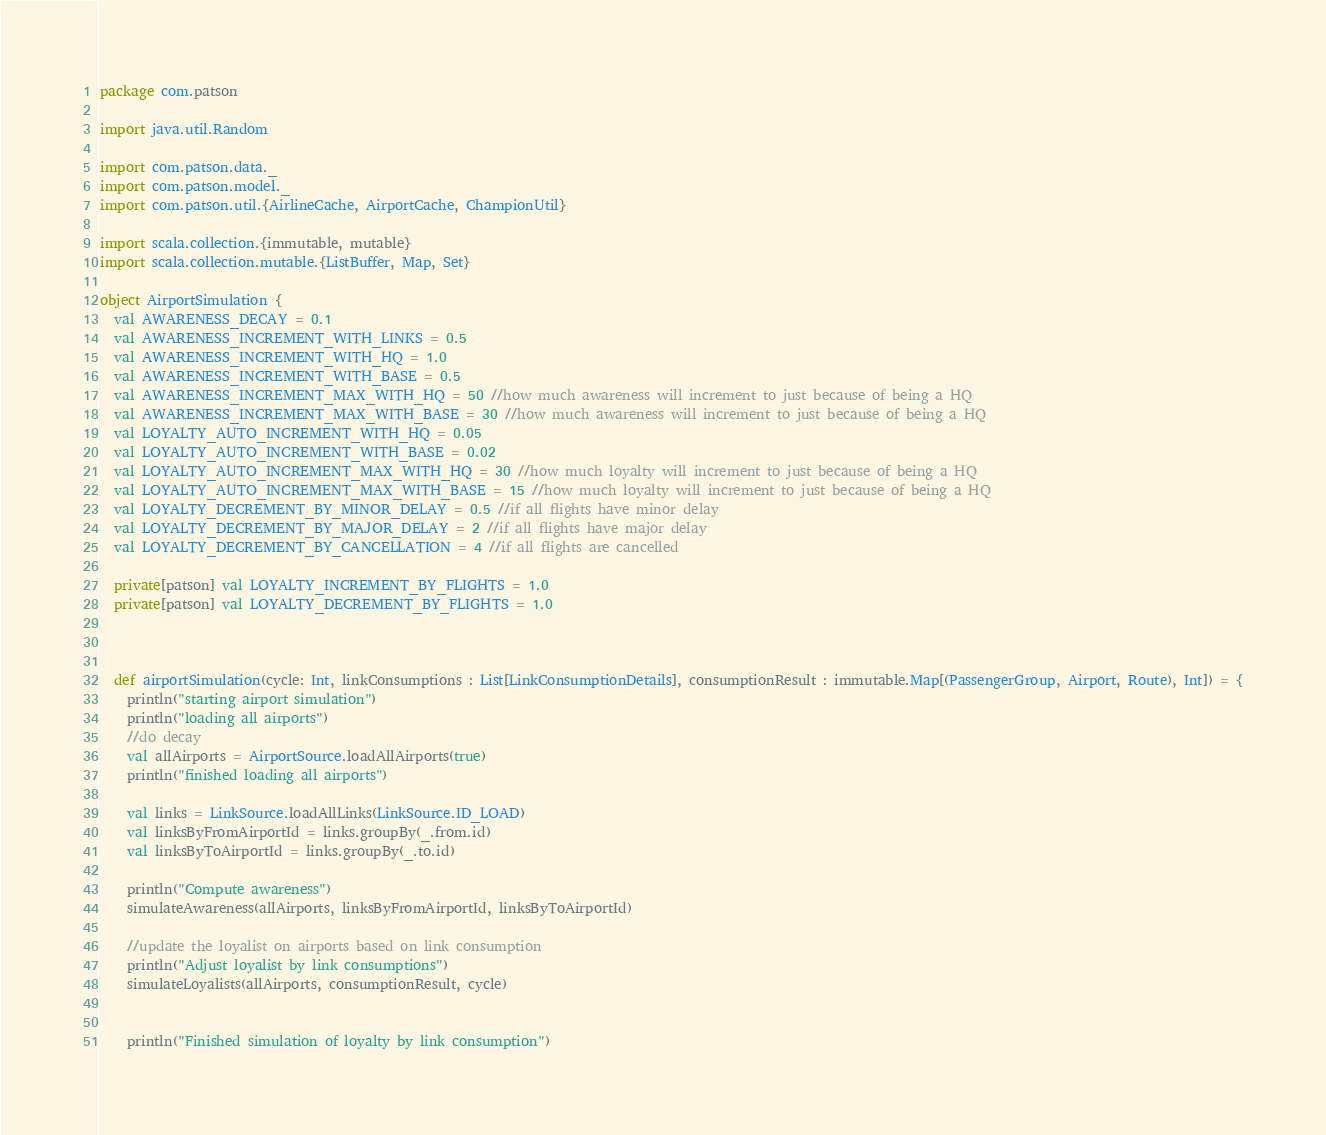<code> <loc_0><loc_0><loc_500><loc_500><_Scala_>package com.patson

import java.util.Random

import com.patson.data._
import com.patson.model._
import com.patson.util.{AirlineCache, AirportCache, ChampionUtil}

import scala.collection.{immutable, mutable}
import scala.collection.mutable.{ListBuffer, Map, Set}

object AirportSimulation {
  val AWARENESS_DECAY = 0.1
  val AWARENESS_INCREMENT_WITH_LINKS = 0.5
  val AWARENESS_INCREMENT_WITH_HQ = 1.0
  val AWARENESS_INCREMENT_WITH_BASE = 0.5
  val AWARENESS_INCREMENT_MAX_WITH_HQ = 50 //how much awareness will increment to just because of being a HQ
  val AWARENESS_INCREMENT_MAX_WITH_BASE = 30 //how much awareness will increment to just because of being a HQ
  val LOYALTY_AUTO_INCREMENT_WITH_HQ = 0.05
  val LOYALTY_AUTO_INCREMENT_WITH_BASE = 0.02
  val LOYALTY_AUTO_INCREMENT_MAX_WITH_HQ = 30 //how much loyalty will increment to just because of being a HQ
  val LOYALTY_AUTO_INCREMENT_MAX_WITH_BASE = 15 //how much loyalty will increment to just because of being a HQ
  val LOYALTY_DECREMENT_BY_MINOR_DELAY = 0.5 //if all flights have minor delay
  val LOYALTY_DECREMENT_BY_MAJOR_DELAY = 2 //if all flights have major delay
  val LOYALTY_DECREMENT_BY_CANCELLATION = 4 //if all flights are cancelled
  
  private[patson] val LOYALTY_INCREMENT_BY_FLIGHTS = 1.0
  private[patson] val LOYALTY_DECREMENT_BY_FLIGHTS = 1.0



  def airportSimulation(cycle: Int, linkConsumptions : List[LinkConsumptionDetails], consumptionResult : immutable.Map[(PassengerGroup, Airport, Route), Int]) = {
    println("starting airport simulation")
    println("loading all airports")
    //do decay
    val allAirports = AirportSource.loadAllAirports(true)
    println("finished loading all airports")

    val links = LinkSource.loadAllLinks(LinkSource.ID_LOAD)
    val linksByFromAirportId = links.groupBy(_.from.id)
    val linksByToAirportId = links.groupBy(_.to.id)

    println("Compute awareness")
    simulateAwareness(allAirports, linksByFromAirportId, linksByToAirportId)

    //update the loyalist on airports based on link consumption
    println("Adjust loyalist by link consumptions")
    simulateLoyalists(allAirports, consumptionResult, cycle)


    println("Finished simulation of loyalty by link consumption")

</code> 